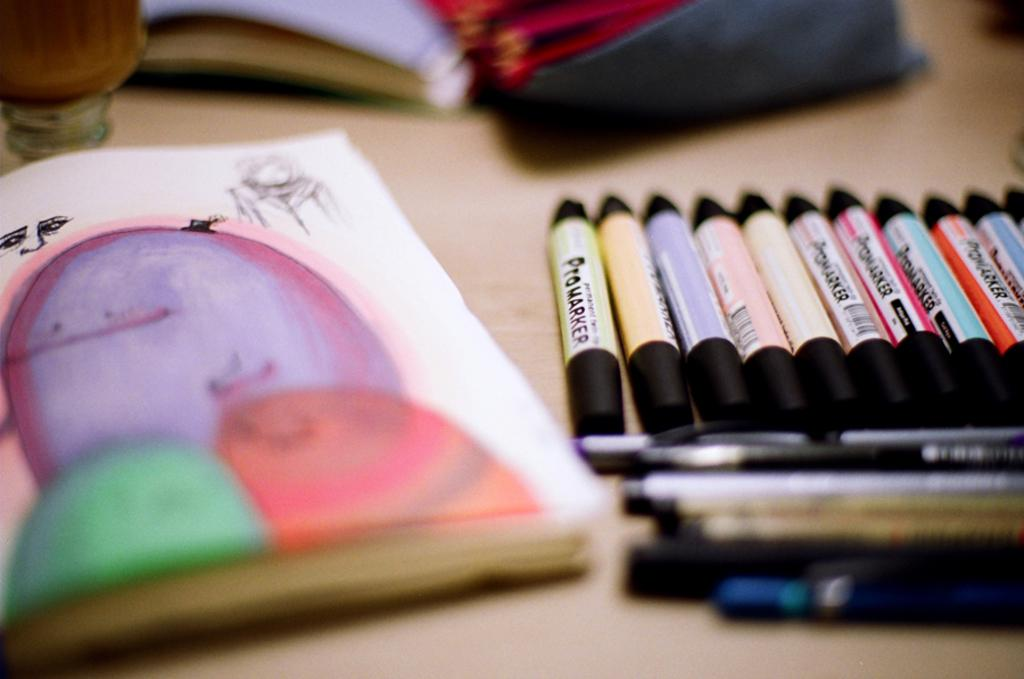<image>
Share a concise interpretation of the image provided. Different colors of Promarkers are lined up on a table by a colorful drawing. 